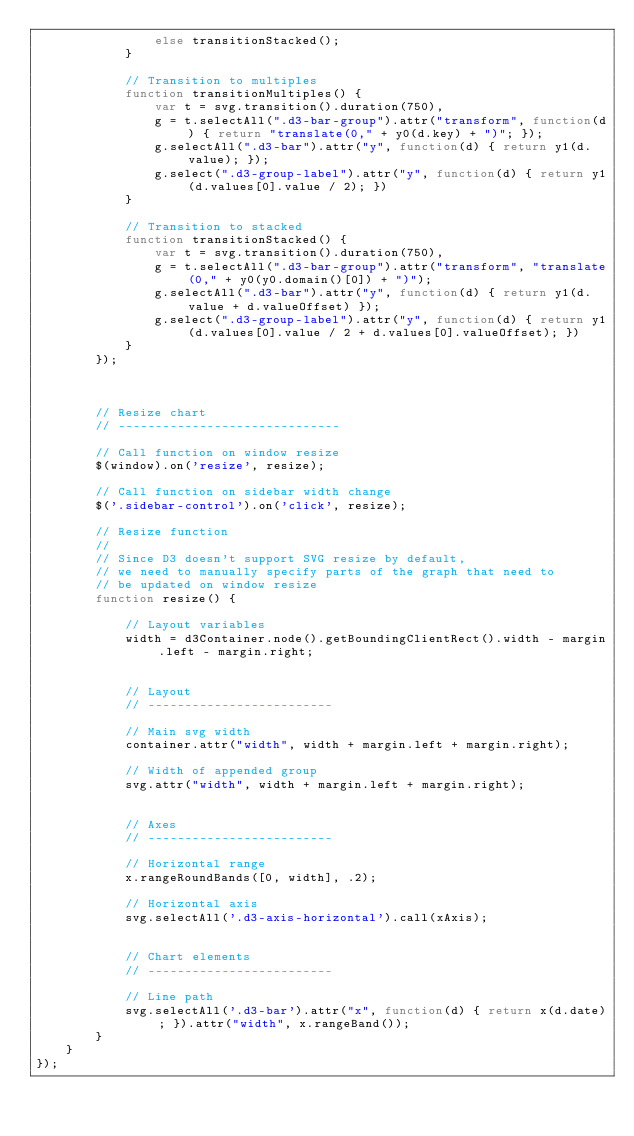<code> <loc_0><loc_0><loc_500><loc_500><_JavaScript_>                else transitionStacked();
            }

            // Transition to multiples
            function transitionMultiples() {
                var t = svg.transition().duration(750),
                g = t.selectAll(".d3-bar-group").attr("transform", function(d) { return "translate(0," + y0(d.key) + ")"; });
                g.selectAll(".d3-bar").attr("y", function(d) { return y1(d.value); });
                g.select(".d3-group-label").attr("y", function(d) { return y1(d.values[0].value / 2); })
            }

            // Transition to stacked
            function transitionStacked() {
                var t = svg.transition().duration(750),
                g = t.selectAll(".d3-bar-group").attr("transform", "translate(0," + y0(y0.domain()[0]) + ")");
                g.selectAll(".d3-bar").attr("y", function(d) { return y1(d.value + d.valueOffset) });
                g.select(".d3-group-label").attr("y", function(d) { return y1(d.values[0].value / 2 + d.values[0].valueOffset); })
            }
        });



        // Resize chart
        // ------------------------------

        // Call function on window resize
        $(window).on('resize', resize);

        // Call function on sidebar width change
        $('.sidebar-control').on('click', resize);

        // Resize function
        // 
        // Since D3 doesn't support SVG resize by default,
        // we need to manually specify parts of the graph that need to 
        // be updated on window resize
        function resize() {

            // Layout variables
            width = d3Container.node().getBoundingClientRect().width - margin.left - margin.right;


            // Layout
            // -------------------------

            // Main svg width
            container.attr("width", width + margin.left + margin.right);

            // Width of appended group
            svg.attr("width", width + margin.left + margin.right);


            // Axes
            // -------------------------

            // Horizontal range
            x.rangeRoundBands([0, width], .2);

            // Horizontal axis
            svg.selectAll('.d3-axis-horizontal').call(xAxis);


            // Chart elements
            // -------------------------

            // Line path
            svg.selectAll('.d3-bar').attr("x", function(d) { return x(d.date); }).attr("width", x.rangeBand());
        }
    }
});
</code> 